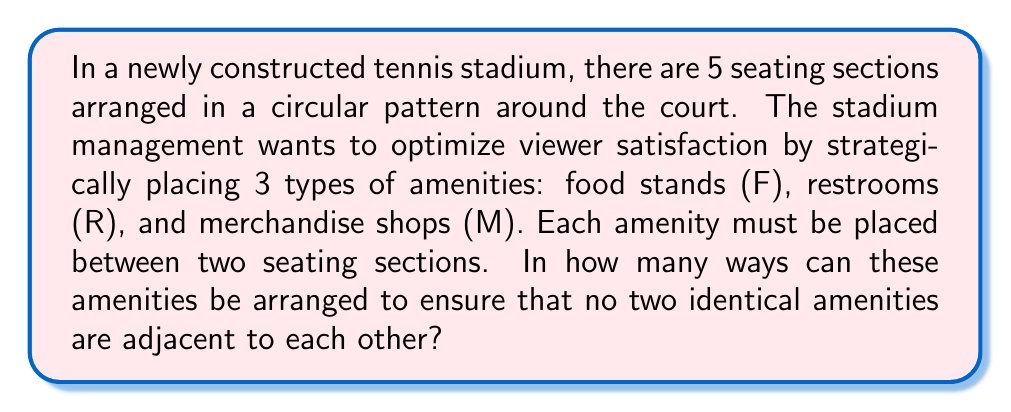Solve this math problem. Let's approach this step-by-step using concepts from graph theory and combinatorics:

1) First, we can model this problem as a circular arrangement. The 5 seating sections can be represented as vertices, and the spaces between them (where amenities will be placed) as edges.

2) We need to place 3 different amenities (F, R, M) in 5 possible positions, with the constraint that no two identical amenities are adjacent.

3) This problem can be solved using the concept of circular permutations with restrictions.

4) Let's start by considering one particular arrangement, say FRMPQ, where P and Q represent the two empty spaces.

5) Now, we can rotate this arrangement in 5 ways (including the original arrangement), which would all be considered the same from the viewer's perspective.

6) So, we need to find the total number of such unique arrangements and divide by 5 to account for rotational symmetry.

7) To count the total arrangements:
   - We have 5 spaces to fill
   - 3 of these spaces will be filled by F, R, and M
   - 2 spaces will remain empty

8) This is equivalent to choosing 2 positions out of 5 to remain empty, which can be done in $\binom{5}{2}$ ways.

9) $\binom{5}{2} = \frac{5!}{2!(5-2)!} = \frac{5 \cdot 4}{2 \cdot 1} = 10$

10) However, we need to divide this by 5 due to rotational symmetry.

11) Therefore, the final number of unique arrangements is $\frac{10}{5} = 2$.
Answer: 2 unique arrangements 